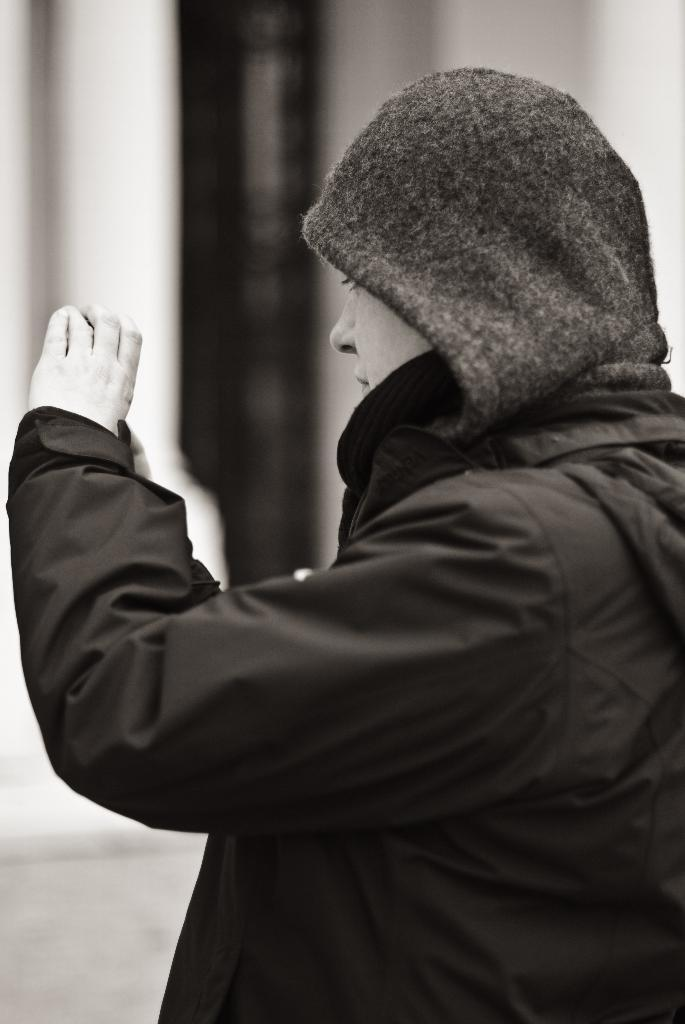What can be seen in the image? There is a person in the image. What is the person wearing? The person is wearing a black sweater. What is the person holding in their hands? The person is holding an object in their hands. What else can be seen in the image besides the person? There are other objects visible in the background of the image. How many deaths are depicted in the image? There are no deaths depicted in the image; it features a person wearing a black sweater and holding an object. What type of vest is the person wearing in the image? The person is not wearing a vest in the image; they are wearing a black sweater. 